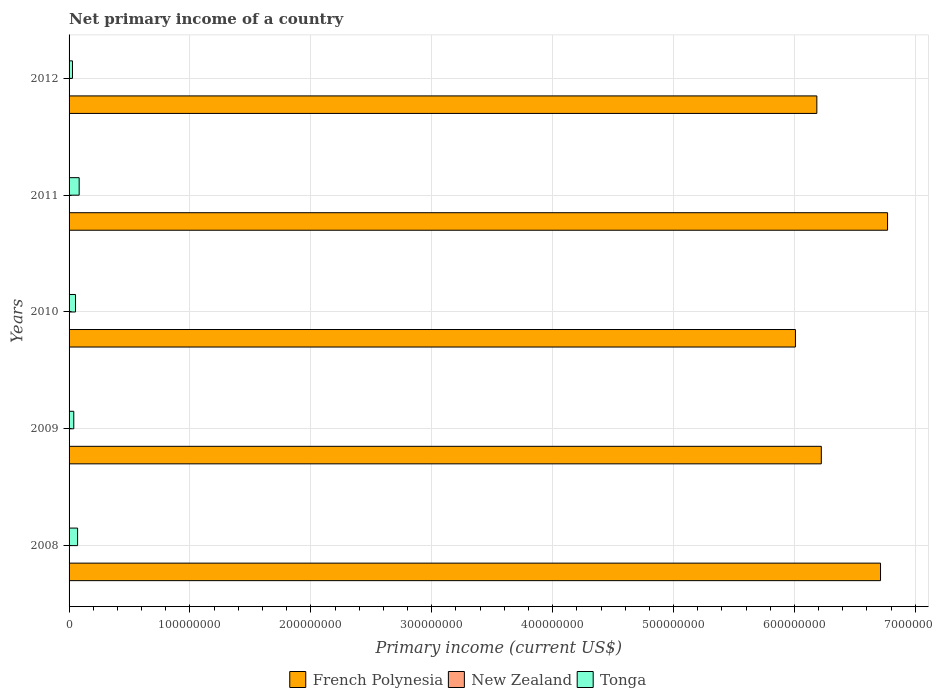Are the number of bars on each tick of the Y-axis equal?
Your response must be concise. Yes. How many bars are there on the 4th tick from the bottom?
Offer a very short reply. 2. What is the primary income in Tonga in 2011?
Ensure brevity in your answer.  8.36e+06. Across all years, what is the maximum primary income in Tonga?
Provide a succinct answer. 8.36e+06. Across all years, what is the minimum primary income in French Polynesia?
Give a very brief answer. 6.01e+08. What is the total primary income in French Polynesia in the graph?
Your response must be concise. 3.19e+09. What is the difference between the primary income in Tonga in 2008 and that in 2010?
Make the answer very short. 1.71e+06. What is the difference between the primary income in Tonga in 2010 and the primary income in French Polynesia in 2011?
Your answer should be very brief. -6.72e+08. What is the average primary income in French Polynesia per year?
Give a very brief answer. 6.38e+08. In the year 2011, what is the difference between the primary income in Tonga and primary income in French Polynesia?
Offer a terse response. -6.69e+08. In how many years, is the primary income in French Polynesia greater than 180000000 US$?
Make the answer very short. 5. What is the ratio of the primary income in French Polynesia in 2009 to that in 2010?
Provide a short and direct response. 1.04. Is the primary income in Tonga in 2009 less than that in 2010?
Offer a very short reply. Yes. Is the difference between the primary income in Tonga in 2008 and 2011 greater than the difference between the primary income in French Polynesia in 2008 and 2011?
Give a very brief answer. Yes. What is the difference between the highest and the second highest primary income in Tonga?
Keep it short and to the point. 1.31e+06. What is the difference between the highest and the lowest primary income in French Polynesia?
Provide a short and direct response. 7.62e+07. Is the sum of the primary income in French Polynesia in 2010 and 2011 greater than the maximum primary income in Tonga across all years?
Your response must be concise. Yes. Is it the case that in every year, the sum of the primary income in New Zealand and primary income in French Polynesia is greater than the primary income in Tonga?
Provide a short and direct response. Yes. Are the values on the major ticks of X-axis written in scientific E-notation?
Provide a short and direct response. No. Does the graph contain any zero values?
Your answer should be compact. Yes. Where does the legend appear in the graph?
Provide a short and direct response. Bottom center. How are the legend labels stacked?
Keep it short and to the point. Horizontal. What is the title of the graph?
Make the answer very short. Net primary income of a country. Does "Sao Tome and Principe" appear as one of the legend labels in the graph?
Offer a terse response. No. What is the label or title of the X-axis?
Make the answer very short. Primary income (current US$). What is the label or title of the Y-axis?
Make the answer very short. Years. What is the Primary income (current US$) in French Polynesia in 2008?
Offer a very short reply. 6.71e+08. What is the Primary income (current US$) of New Zealand in 2008?
Give a very brief answer. 0. What is the Primary income (current US$) in Tonga in 2008?
Keep it short and to the point. 7.04e+06. What is the Primary income (current US$) in French Polynesia in 2009?
Give a very brief answer. 6.22e+08. What is the Primary income (current US$) of Tonga in 2009?
Give a very brief answer. 3.90e+06. What is the Primary income (current US$) of French Polynesia in 2010?
Ensure brevity in your answer.  6.01e+08. What is the Primary income (current US$) in New Zealand in 2010?
Ensure brevity in your answer.  0. What is the Primary income (current US$) of Tonga in 2010?
Ensure brevity in your answer.  5.34e+06. What is the Primary income (current US$) of French Polynesia in 2011?
Make the answer very short. 6.77e+08. What is the Primary income (current US$) of New Zealand in 2011?
Offer a very short reply. 0. What is the Primary income (current US$) in Tonga in 2011?
Your answer should be very brief. 8.36e+06. What is the Primary income (current US$) in French Polynesia in 2012?
Ensure brevity in your answer.  6.19e+08. What is the Primary income (current US$) in New Zealand in 2012?
Offer a terse response. 0. What is the Primary income (current US$) in Tonga in 2012?
Your answer should be compact. 2.83e+06. Across all years, what is the maximum Primary income (current US$) in French Polynesia?
Make the answer very short. 6.77e+08. Across all years, what is the maximum Primary income (current US$) of Tonga?
Ensure brevity in your answer.  8.36e+06. Across all years, what is the minimum Primary income (current US$) in French Polynesia?
Your response must be concise. 6.01e+08. Across all years, what is the minimum Primary income (current US$) of Tonga?
Make the answer very short. 2.83e+06. What is the total Primary income (current US$) of French Polynesia in the graph?
Give a very brief answer. 3.19e+09. What is the total Primary income (current US$) in New Zealand in the graph?
Keep it short and to the point. 0. What is the total Primary income (current US$) of Tonga in the graph?
Ensure brevity in your answer.  2.75e+07. What is the difference between the Primary income (current US$) in French Polynesia in 2008 and that in 2009?
Your response must be concise. 4.90e+07. What is the difference between the Primary income (current US$) of Tonga in 2008 and that in 2009?
Your answer should be very brief. 3.14e+06. What is the difference between the Primary income (current US$) of French Polynesia in 2008 and that in 2010?
Your response must be concise. 7.04e+07. What is the difference between the Primary income (current US$) of Tonga in 2008 and that in 2010?
Your response must be concise. 1.71e+06. What is the difference between the Primary income (current US$) of French Polynesia in 2008 and that in 2011?
Make the answer very short. -5.82e+06. What is the difference between the Primary income (current US$) in Tonga in 2008 and that in 2011?
Provide a short and direct response. -1.31e+06. What is the difference between the Primary income (current US$) in French Polynesia in 2008 and that in 2012?
Offer a terse response. 5.27e+07. What is the difference between the Primary income (current US$) in Tonga in 2008 and that in 2012?
Your response must be concise. 4.22e+06. What is the difference between the Primary income (current US$) of French Polynesia in 2009 and that in 2010?
Your answer should be compact. 2.14e+07. What is the difference between the Primary income (current US$) in Tonga in 2009 and that in 2010?
Offer a terse response. -1.44e+06. What is the difference between the Primary income (current US$) in French Polynesia in 2009 and that in 2011?
Ensure brevity in your answer.  -5.48e+07. What is the difference between the Primary income (current US$) of Tonga in 2009 and that in 2011?
Ensure brevity in your answer.  -4.46e+06. What is the difference between the Primary income (current US$) of French Polynesia in 2009 and that in 2012?
Ensure brevity in your answer.  3.70e+06. What is the difference between the Primary income (current US$) of Tonga in 2009 and that in 2012?
Keep it short and to the point. 1.07e+06. What is the difference between the Primary income (current US$) of French Polynesia in 2010 and that in 2011?
Offer a terse response. -7.62e+07. What is the difference between the Primary income (current US$) of Tonga in 2010 and that in 2011?
Give a very brief answer. -3.02e+06. What is the difference between the Primary income (current US$) in French Polynesia in 2010 and that in 2012?
Your answer should be compact. -1.77e+07. What is the difference between the Primary income (current US$) in Tonga in 2010 and that in 2012?
Keep it short and to the point. 2.51e+06. What is the difference between the Primary income (current US$) in French Polynesia in 2011 and that in 2012?
Your response must be concise. 5.85e+07. What is the difference between the Primary income (current US$) of Tonga in 2011 and that in 2012?
Keep it short and to the point. 5.53e+06. What is the difference between the Primary income (current US$) in French Polynesia in 2008 and the Primary income (current US$) in Tonga in 2009?
Your answer should be very brief. 6.67e+08. What is the difference between the Primary income (current US$) of French Polynesia in 2008 and the Primary income (current US$) of Tonga in 2010?
Keep it short and to the point. 6.66e+08. What is the difference between the Primary income (current US$) in French Polynesia in 2008 and the Primary income (current US$) in Tonga in 2011?
Your response must be concise. 6.63e+08. What is the difference between the Primary income (current US$) of French Polynesia in 2008 and the Primary income (current US$) of Tonga in 2012?
Provide a short and direct response. 6.68e+08. What is the difference between the Primary income (current US$) in French Polynesia in 2009 and the Primary income (current US$) in Tonga in 2010?
Offer a very short reply. 6.17e+08. What is the difference between the Primary income (current US$) in French Polynesia in 2009 and the Primary income (current US$) in Tonga in 2011?
Give a very brief answer. 6.14e+08. What is the difference between the Primary income (current US$) of French Polynesia in 2009 and the Primary income (current US$) of Tonga in 2012?
Ensure brevity in your answer.  6.19e+08. What is the difference between the Primary income (current US$) of French Polynesia in 2010 and the Primary income (current US$) of Tonga in 2011?
Provide a succinct answer. 5.92e+08. What is the difference between the Primary income (current US$) of French Polynesia in 2010 and the Primary income (current US$) of Tonga in 2012?
Provide a short and direct response. 5.98e+08. What is the difference between the Primary income (current US$) in French Polynesia in 2011 and the Primary income (current US$) in Tonga in 2012?
Make the answer very short. 6.74e+08. What is the average Primary income (current US$) of French Polynesia per year?
Give a very brief answer. 6.38e+08. What is the average Primary income (current US$) of New Zealand per year?
Ensure brevity in your answer.  0. What is the average Primary income (current US$) of Tonga per year?
Keep it short and to the point. 5.49e+06. In the year 2008, what is the difference between the Primary income (current US$) in French Polynesia and Primary income (current US$) in Tonga?
Provide a succinct answer. 6.64e+08. In the year 2009, what is the difference between the Primary income (current US$) in French Polynesia and Primary income (current US$) in Tonga?
Provide a short and direct response. 6.18e+08. In the year 2010, what is the difference between the Primary income (current US$) of French Polynesia and Primary income (current US$) of Tonga?
Make the answer very short. 5.96e+08. In the year 2011, what is the difference between the Primary income (current US$) in French Polynesia and Primary income (current US$) in Tonga?
Keep it short and to the point. 6.69e+08. In the year 2012, what is the difference between the Primary income (current US$) in French Polynesia and Primary income (current US$) in Tonga?
Make the answer very short. 6.16e+08. What is the ratio of the Primary income (current US$) in French Polynesia in 2008 to that in 2009?
Offer a very short reply. 1.08. What is the ratio of the Primary income (current US$) in Tonga in 2008 to that in 2009?
Your answer should be compact. 1.81. What is the ratio of the Primary income (current US$) in French Polynesia in 2008 to that in 2010?
Provide a short and direct response. 1.12. What is the ratio of the Primary income (current US$) of Tonga in 2008 to that in 2010?
Provide a short and direct response. 1.32. What is the ratio of the Primary income (current US$) in French Polynesia in 2008 to that in 2011?
Offer a very short reply. 0.99. What is the ratio of the Primary income (current US$) in Tonga in 2008 to that in 2011?
Your answer should be very brief. 0.84. What is the ratio of the Primary income (current US$) in French Polynesia in 2008 to that in 2012?
Your answer should be compact. 1.09. What is the ratio of the Primary income (current US$) of Tonga in 2008 to that in 2012?
Give a very brief answer. 2.49. What is the ratio of the Primary income (current US$) in French Polynesia in 2009 to that in 2010?
Make the answer very short. 1.04. What is the ratio of the Primary income (current US$) in Tonga in 2009 to that in 2010?
Offer a very short reply. 0.73. What is the ratio of the Primary income (current US$) in French Polynesia in 2009 to that in 2011?
Offer a very short reply. 0.92. What is the ratio of the Primary income (current US$) in Tonga in 2009 to that in 2011?
Your answer should be very brief. 0.47. What is the ratio of the Primary income (current US$) in French Polynesia in 2009 to that in 2012?
Ensure brevity in your answer.  1.01. What is the ratio of the Primary income (current US$) in Tonga in 2009 to that in 2012?
Offer a terse response. 1.38. What is the ratio of the Primary income (current US$) of French Polynesia in 2010 to that in 2011?
Make the answer very short. 0.89. What is the ratio of the Primary income (current US$) of Tonga in 2010 to that in 2011?
Ensure brevity in your answer.  0.64. What is the ratio of the Primary income (current US$) in French Polynesia in 2010 to that in 2012?
Offer a very short reply. 0.97. What is the ratio of the Primary income (current US$) of Tonga in 2010 to that in 2012?
Offer a terse response. 1.89. What is the ratio of the Primary income (current US$) of French Polynesia in 2011 to that in 2012?
Your answer should be compact. 1.09. What is the ratio of the Primary income (current US$) in Tonga in 2011 to that in 2012?
Give a very brief answer. 2.95. What is the difference between the highest and the second highest Primary income (current US$) in French Polynesia?
Ensure brevity in your answer.  5.82e+06. What is the difference between the highest and the second highest Primary income (current US$) of Tonga?
Your answer should be very brief. 1.31e+06. What is the difference between the highest and the lowest Primary income (current US$) in French Polynesia?
Offer a terse response. 7.62e+07. What is the difference between the highest and the lowest Primary income (current US$) in Tonga?
Your response must be concise. 5.53e+06. 